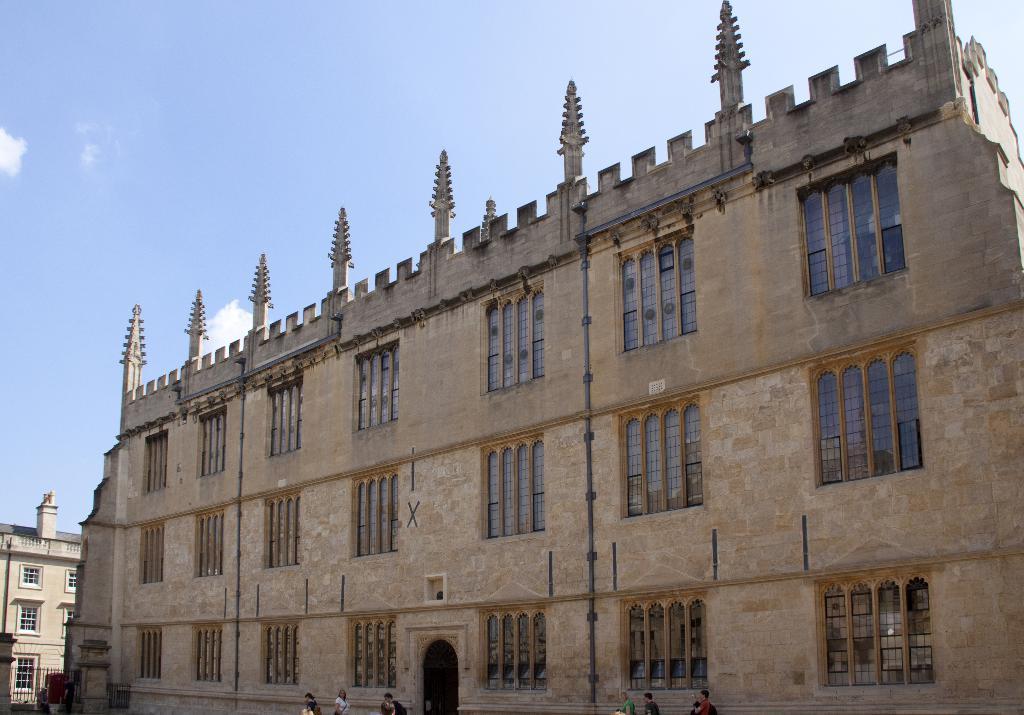Can you describe this image briefly? In this image there is a building for that building there are windows and a entrance, in front of the building people walking in the background there is a sky. 